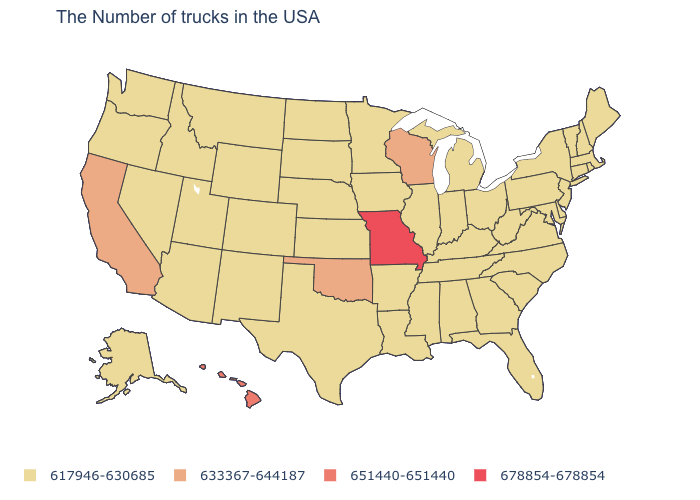Does Florida have a higher value than Illinois?
Write a very short answer. No. What is the value of Maine?
Quick response, please. 617946-630685. Among the states that border West Virginia , which have the highest value?
Give a very brief answer. Maryland, Pennsylvania, Virginia, Ohio, Kentucky. What is the value of Connecticut?
Quick response, please. 617946-630685. Among the states that border Wisconsin , which have the lowest value?
Concise answer only. Michigan, Illinois, Minnesota, Iowa. What is the highest value in states that border Alabama?
Give a very brief answer. 617946-630685. What is the lowest value in states that border New Mexico?
Quick response, please. 617946-630685. What is the value of Oklahoma?
Short answer required. 633367-644187. What is the lowest value in the USA?
Give a very brief answer. 617946-630685. Name the states that have a value in the range 678854-678854?
Give a very brief answer. Missouri. What is the lowest value in the Northeast?
Quick response, please. 617946-630685. What is the value of South Carolina?
Concise answer only. 617946-630685. Name the states that have a value in the range 633367-644187?
Quick response, please. Wisconsin, Oklahoma, California. Does Missouri have the highest value in the USA?
Be succinct. Yes. Does Missouri have the highest value in the USA?
Short answer required. Yes. 